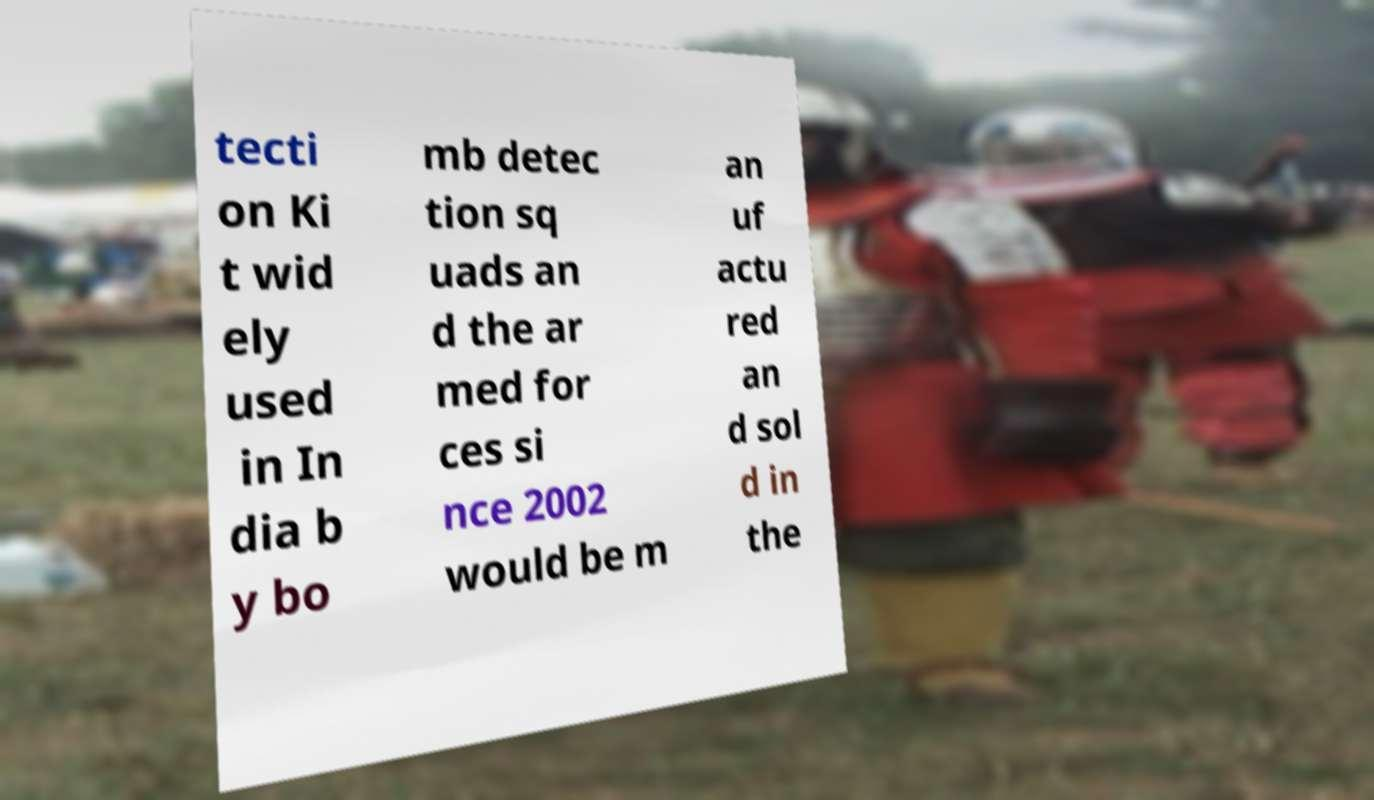Please read and relay the text visible in this image. What does it say? tecti on Ki t wid ely used in In dia b y bo mb detec tion sq uads an d the ar med for ces si nce 2002 would be m an uf actu red an d sol d in the 